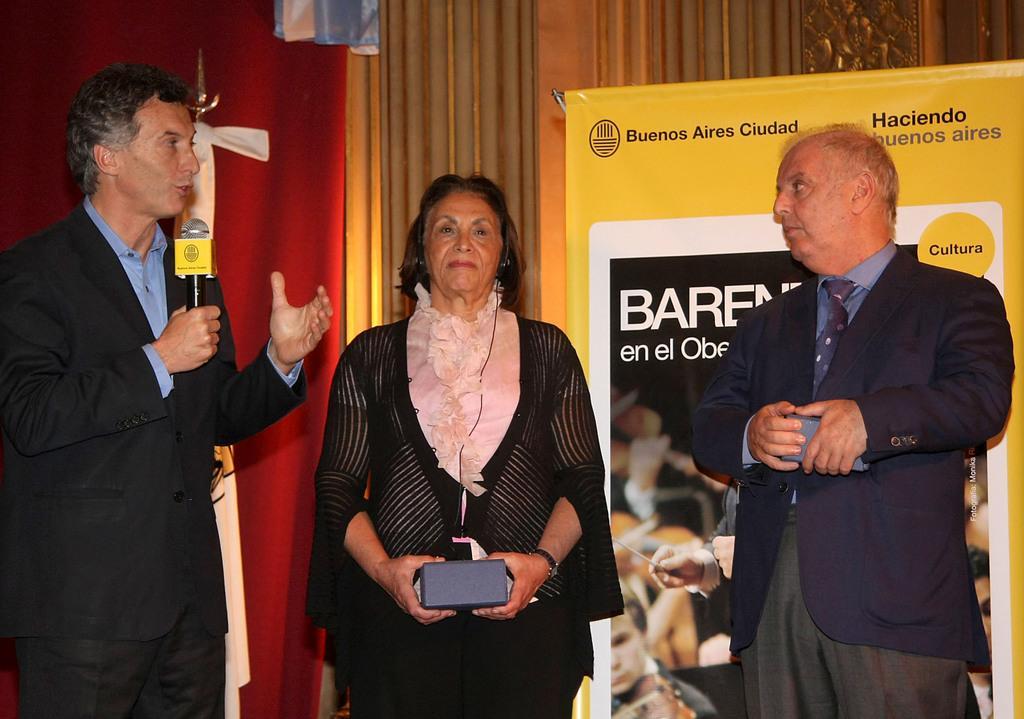How would you summarize this image in a sentence or two? This picture shows couple of men standing and we see a woman Standing and holding a box in a hand and we see a man speaking with the help of a microphone and we see a advertisement hoarding on the back. 